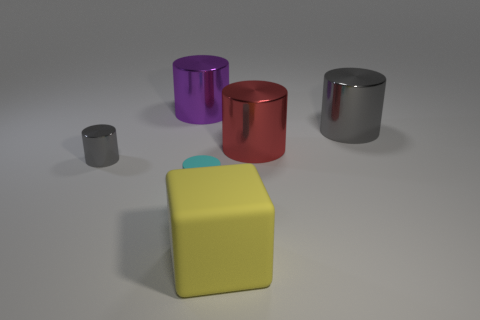How many objects are there in total, and what colors are they? There are five objects in total. Starting from the left, we have a small gray cylinder, a big purple cylinder, a big red cylinder, a big silver cylinder, and in front, a large yellow cube.  Do these objects have any particular arrangement or pattern? The objects are arranged with the cylinders in a row by size, transitioning smoothly from smallest to largest. The yellow cube is positioned in front, breaking the cylinder pattern with its distinct shape and vibrant color. 